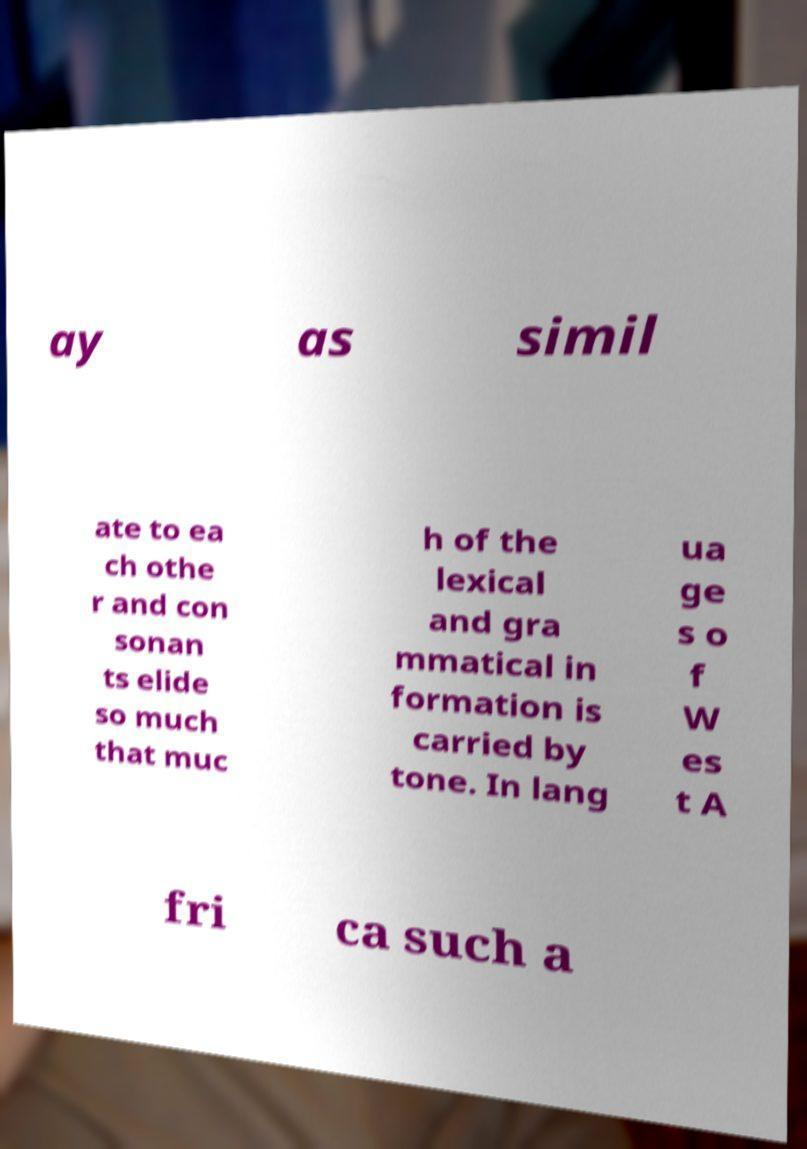There's text embedded in this image that I need extracted. Can you transcribe it verbatim? ay as simil ate to ea ch othe r and con sonan ts elide so much that muc h of the lexical and gra mmatical in formation is carried by tone. In lang ua ge s o f W es t A fri ca such a 